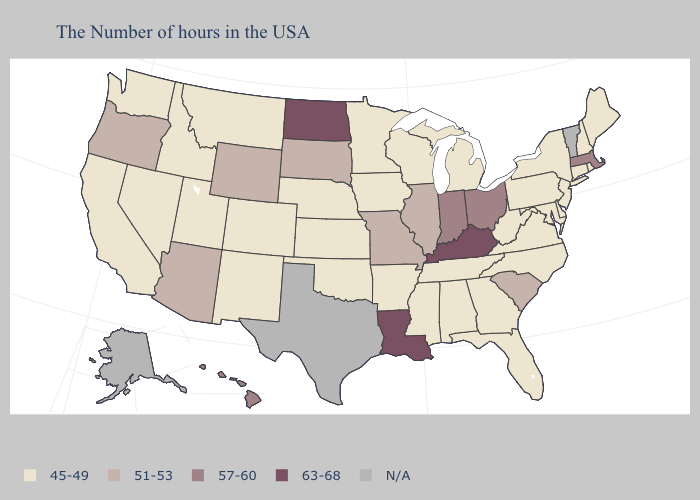Does the first symbol in the legend represent the smallest category?
Answer briefly. Yes. What is the value of Idaho?
Keep it brief. 45-49. Does Kentucky have the lowest value in the USA?
Short answer required. No. What is the value of Connecticut?
Write a very short answer. 45-49. What is the value of Connecticut?
Keep it brief. 45-49. What is the value of Illinois?
Keep it brief. 51-53. Does Virginia have the highest value in the USA?
Give a very brief answer. No. What is the lowest value in the USA?
Keep it brief. 45-49. Which states hav the highest value in the MidWest?
Short answer required. North Dakota. Name the states that have a value in the range 57-60?
Quick response, please. Massachusetts, Ohio, Indiana, Hawaii. What is the value of Delaware?
Concise answer only. 45-49. Does Indiana have the lowest value in the USA?
Keep it brief. No. What is the value of Alaska?
Be succinct. N/A. Among the states that border Ohio , does Kentucky have the lowest value?
Short answer required. No. 